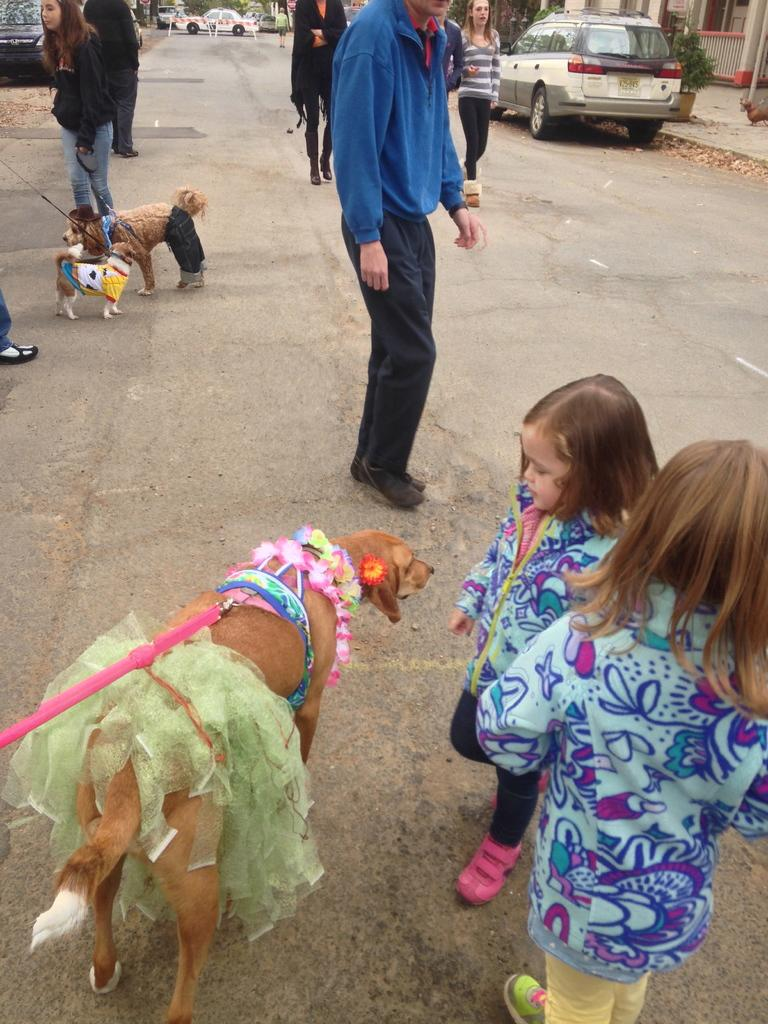How many girls are in the image? There are two girls in the image. What are the girls doing in the image? The girls are standing beside a dog. Can you describe the dog in the image? The dog is decorated. What else can be seen in the background of the image? There are people in the background of the image. Are there any other animals in the image besides the dog? Yes, there are other dogs in the image. What else is present in the image? There is a car parked in the image. What type of dinner is being served in the image? There is no dinner present in the image. How much profit did the girls make from the dog in the image? There is no indication of profit or any financial transaction in the image. 